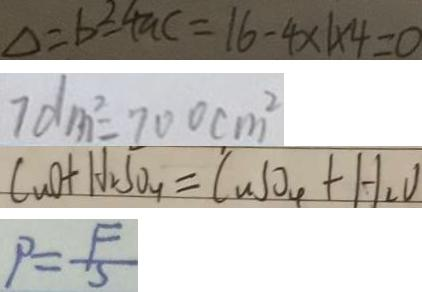<formula> <loc_0><loc_0><loc_500><loc_500>\Delta = b ^ { 2 } - 4 a c = 1 6 - 4 \times 1 \times 4 = 0 
 7 d m ^ { 2 } = 7 0 0 c m ^ { 2 } 
 C u O + H _ { 2 } S O _ { 4 } = C u S O _ { 4 } + H _ { 2 } O 
 P = \frac { F } { S }</formula> 